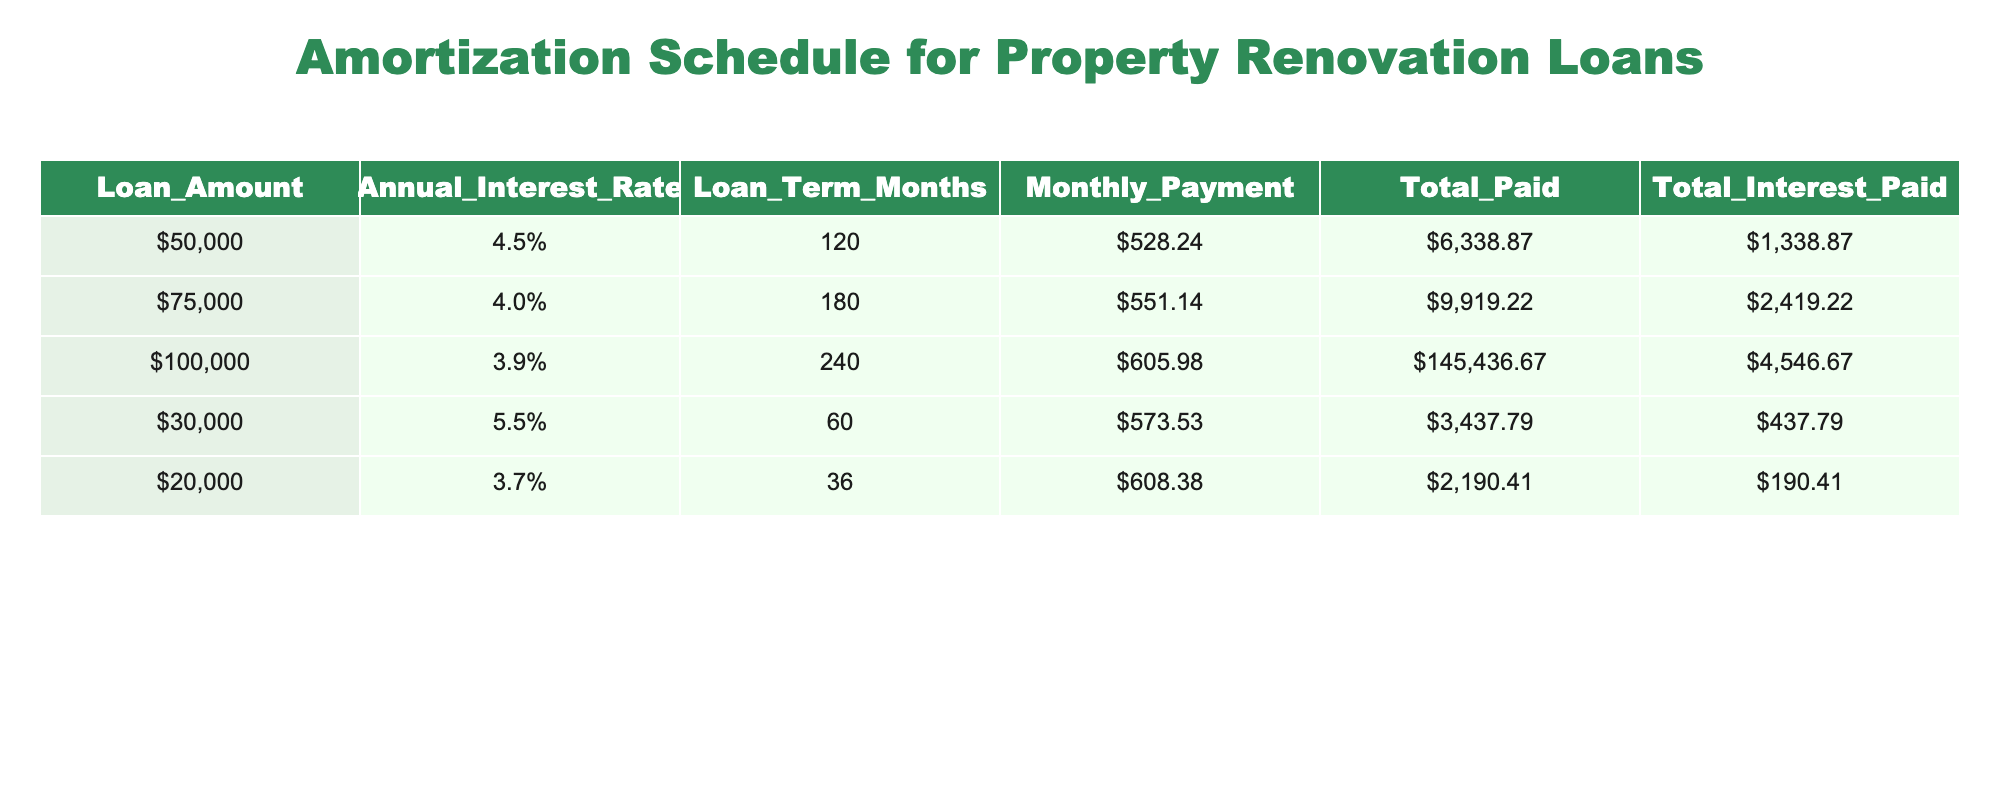What is the monthly payment for the loan of $100,000? The loan amount of $100,000 has an associated monthly payment listed in the table, which is found under the "Monthly Payment" column. The value is $605.98.
Answer: $605.98 What is the total interest paid for the loan of $30,000? The total interest paid for the loan of $30,000 is found in the "Total Interest Paid" column specifically for that loan amount, which is $437.79.
Answer: $437.79 Is the annual interest rate for the loan of $50,000 greater than 4.0%? The loan amount of $50,000 has an annual interest rate listed in the table under the "Annual Interest Rate" column, which is 4.5%. Since 4.5% is greater than 4.0%, the answer is yes.
Answer: Yes What is the total amount paid for the loan of $75,000 compared to the loan of $30,000? The total paid for the loan of $75,000 is $9,919.22 and for the loan of $30,000, it is $3,437.79. When we subtract the amount for the $30,000 loan from the $75,000 loan: $9,919.22 - $3,437.79 = $6,481.43. Thus, the loan of $75,000 has been paid $6,481.43 more than the loan of $30,000.
Answer: $6,481.43 What is the average monthly payment among all the loans listed? To find the average monthly payment, we first sum up all the monthly payments: $528.24 + $551.14 + $605.98 + $573.53 + $608.38 = $2,867.27. Then, we divide by the number of loans, which is 5: $2,867.27 / 5 = $573.45. Therefore, the average monthly payment is $573.45.
Answer: $573.45 Is the total interest paid on the $200,000 loan less than the total paid on the $50,000 loan? The table does not contain a loan for $200,000; it only shows loans for amounts up to $100,000. Therefore, the statement cannot be evaluated and is treated as false since the comparison cannot be made.
Answer: No How much total interest is paid across all loans combined? To calculate the total interest paid across all loans, we add the total interest for each loan: $1,338.87 + $2,419.22 + $4,546.67 + $437.79 + $190.41 = $8,932.96. Hence, the total interest paid for all loans is $8,932.96.
Answer: $8,932.96 